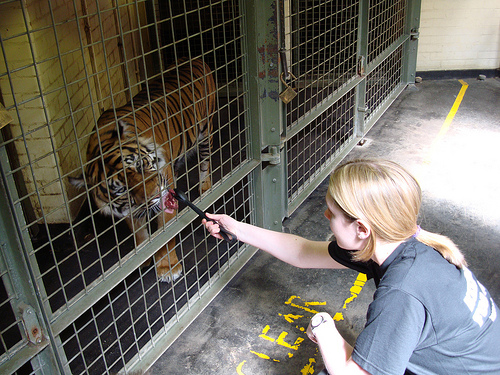<image>
Can you confirm if the tiger is on the lock? No. The tiger is not positioned on the lock. They may be near each other, but the tiger is not supported by or resting on top of the lock. 